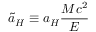<formula> <loc_0><loc_0><loc_500><loc_500>\tilde { a } _ { H } \equiv a _ { H } \frac { M c ^ { 2 } } { E }</formula> 